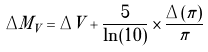Convert formula to latex. <formula><loc_0><loc_0><loc_500><loc_500>\Delta M _ { V } = \Delta V + \frac { 5 } { \ln ( 1 0 ) } \times \frac { \Delta ( \pi ) } { \pi }</formula> 